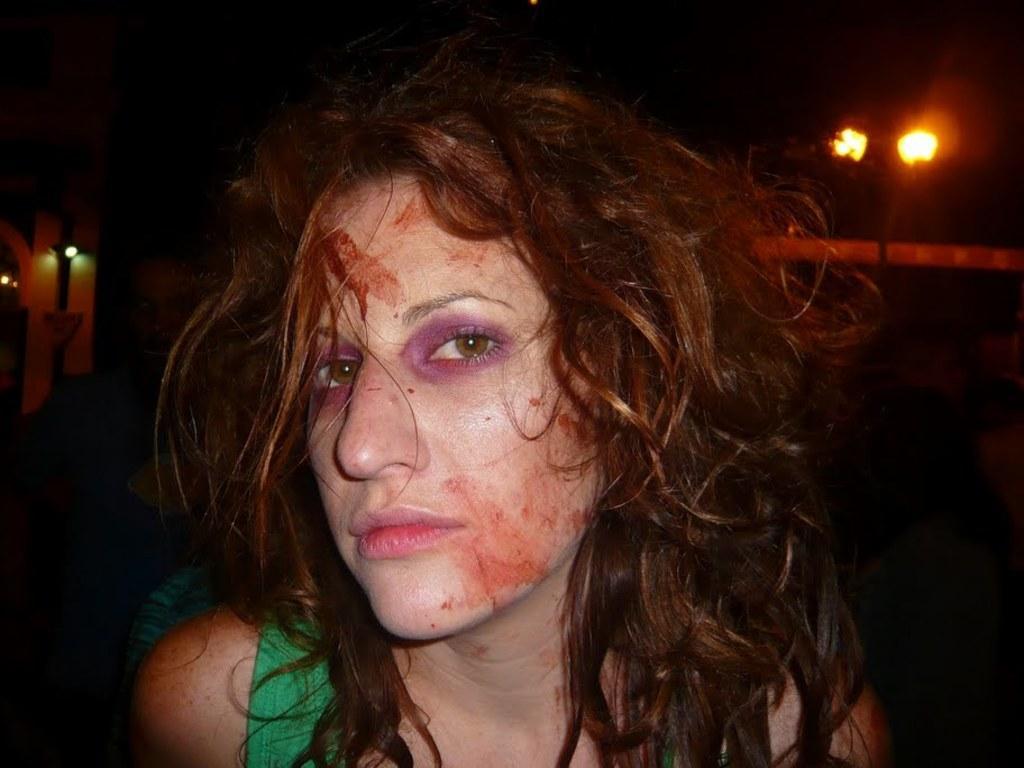In one or two sentences, can you explain what this image depicts? Here I can see a woman looking at the picture. I can see few red color marks on her face. In the background there are few lights in the dark. 